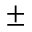<formula> <loc_0><loc_0><loc_500><loc_500>\pm</formula> 